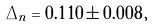Convert formula to latex. <formula><loc_0><loc_0><loc_500><loc_500>\Delta _ { n } = 0 . 1 1 0 \pm 0 . 0 0 8 \, ,</formula> 